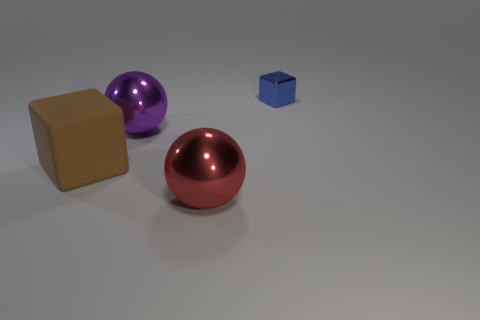Are there any small purple metallic objects that have the same shape as the brown thing?
Your answer should be very brief. No. The large metal object that is behind the cube in front of the blue object is what shape?
Ensure brevity in your answer.  Sphere. How many cubes are gray rubber objects or metal things?
Keep it short and to the point. 1. Do the shiny thing that is in front of the rubber block and the metallic object that is right of the large red metallic sphere have the same shape?
Your answer should be compact. No. What color is the thing that is behind the brown block and in front of the small blue metallic cube?
Offer a terse response. Purple. Do the small thing and the thing in front of the big brown block have the same color?
Keep it short and to the point. No. There is a metal object that is both behind the big brown rubber block and to the left of the tiny thing; how big is it?
Make the answer very short. Large. How many other objects are there of the same color as the small cube?
Give a very brief answer. 0. What size is the metal object in front of the big metal thing that is behind the cube that is left of the tiny blue block?
Your answer should be compact. Large. Are there any purple objects in front of the large matte block?
Offer a very short reply. No. 